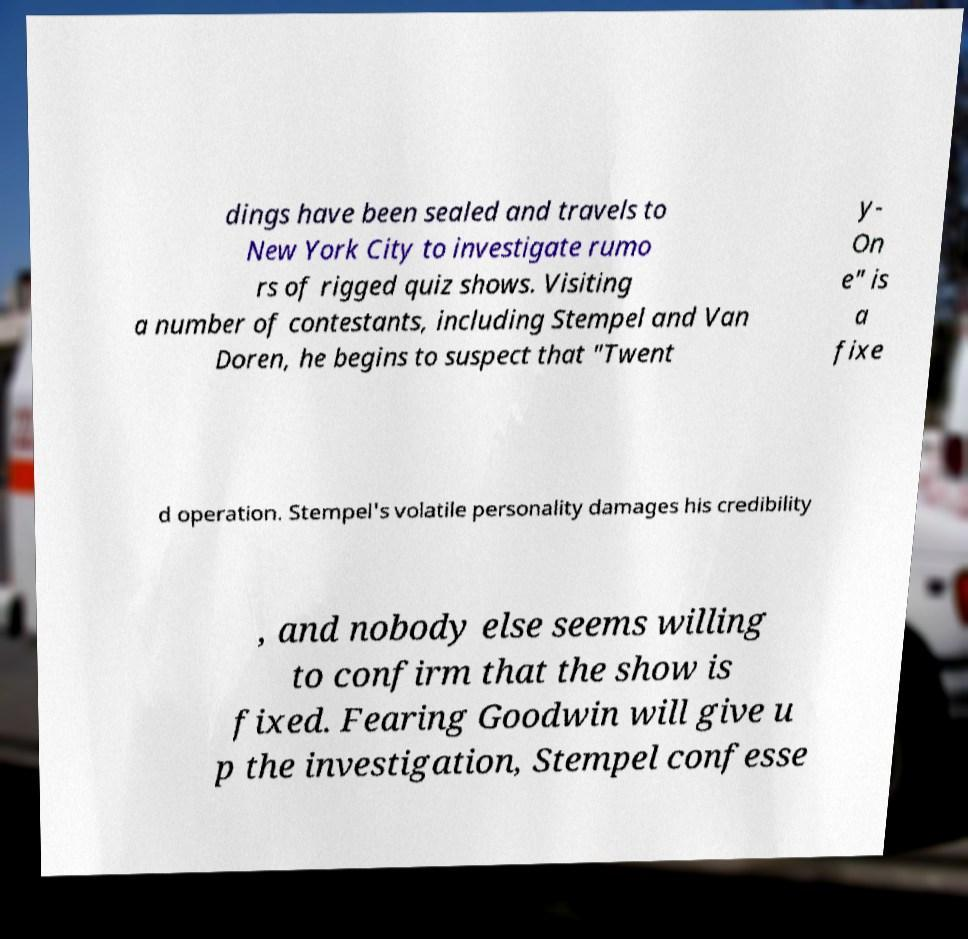Can you accurately transcribe the text from the provided image for me? dings have been sealed and travels to New York City to investigate rumo rs of rigged quiz shows. Visiting a number of contestants, including Stempel and Van Doren, he begins to suspect that "Twent y- On e" is a fixe d operation. Stempel's volatile personality damages his credibility , and nobody else seems willing to confirm that the show is fixed. Fearing Goodwin will give u p the investigation, Stempel confesse 